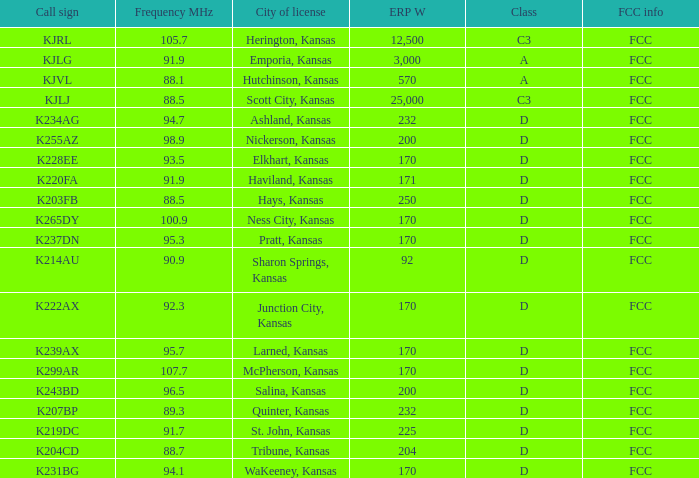3 and a call sign of k234ag? D. 